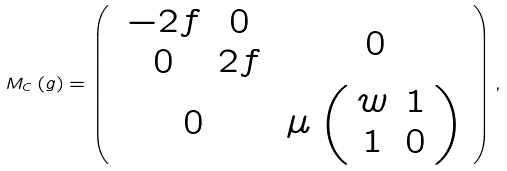<formula> <loc_0><loc_0><loc_500><loc_500>M _ { C } \left ( g \right ) = \left ( \begin{array} [ c ] { c c } \begin{array} [ c ] { c c } - 2 f & 0 \\ 0 & 2 f \end{array} & 0 \\ 0 & \mu \left ( \begin{array} [ c ] { c c } w & 1 \\ 1 & 0 \end{array} \right ) \end{array} \right ) ,</formula> 